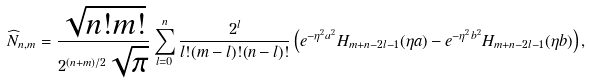Convert formula to latex. <formula><loc_0><loc_0><loc_500><loc_500>\widehat { N } _ { n , m } = \frac { \sqrt { n ! m ! } } { 2 ^ { ( n + m ) / 2 } \sqrt { \pi } } \sum _ { l = 0 } ^ { n } \frac { 2 ^ { l } } { l ! ( m - l ) ! ( n - l ) ! } \left ( e ^ { - \eta ^ { 2 } a ^ { 2 } } H _ { m + n - 2 l - 1 } ( \eta a ) - e ^ { - \eta ^ { 2 } b ^ { 2 } } H _ { m + n - 2 l - 1 } ( \eta b ) \right ) ,</formula> 